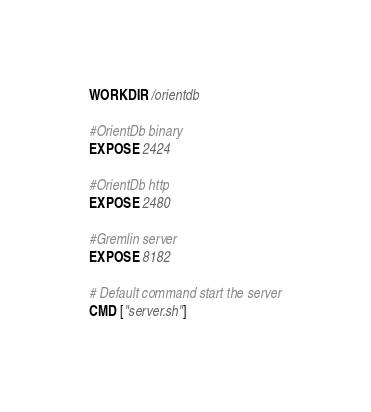Convert code to text. <code><loc_0><loc_0><loc_500><loc_500><_Dockerfile_>
WORKDIR /orientdb

#OrientDb binary
EXPOSE 2424

#OrientDb http
EXPOSE 2480

#Gremlin server
EXPOSE 8182

# Default command start the server
CMD ["server.sh"]

</code> 